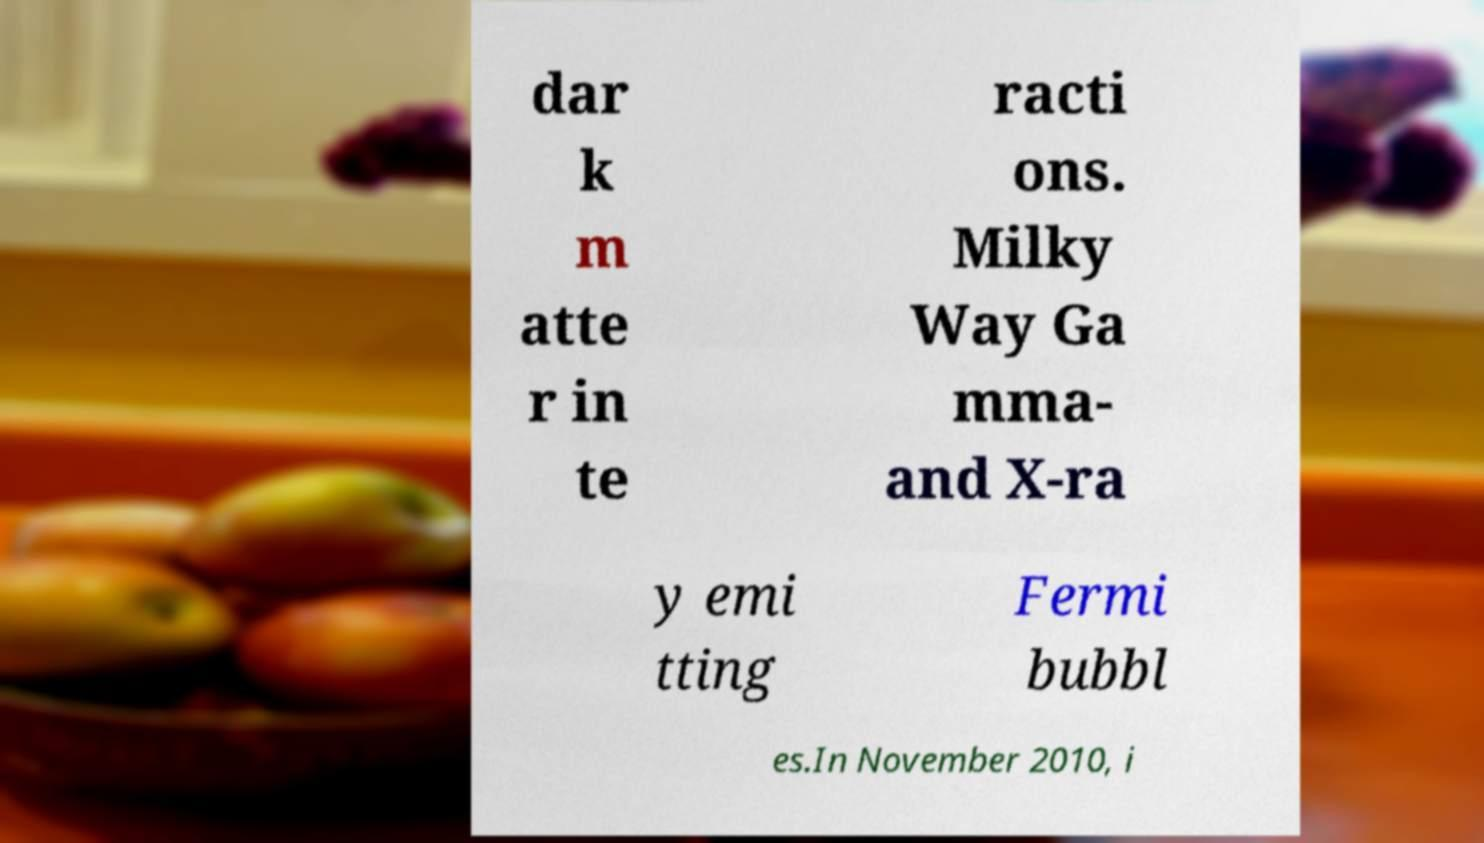What messages or text are displayed in this image? I need them in a readable, typed format. dar k m atte r in te racti ons. Milky Way Ga mma- and X-ra y emi tting Fermi bubbl es.In November 2010, i 